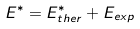Convert formula to latex. <formula><loc_0><loc_0><loc_500><loc_500>E ^ { * } = E ^ { * } _ { t h e r } + E _ { e x p }</formula> 